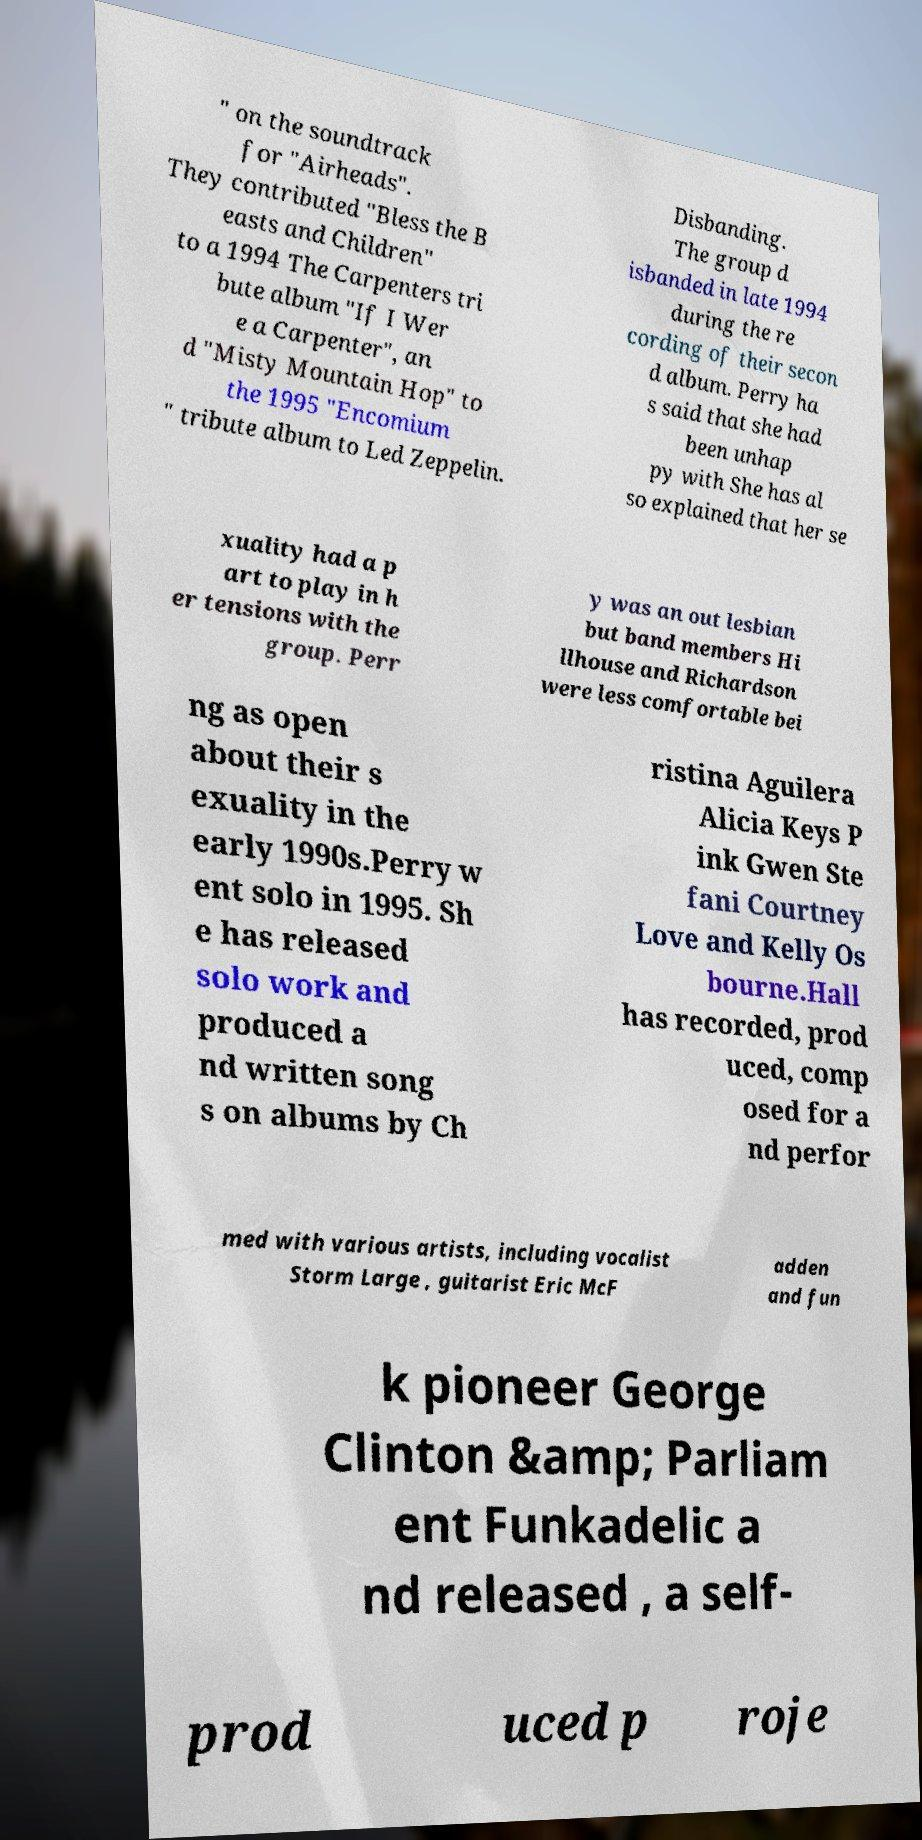I need the written content from this picture converted into text. Can you do that? " on the soundtrack for "Airheads". They contributed "Bless the B easts and Children" to a 1994 The Carpenters tri bute album "If I Wer e a Carpenter", an d "Misty Mountain Hop" to the 1995 "Encomium " tribute album to Led Zeppelin. Disbanding. The group d isbanded in late 1994 during the re cording of their secon d album. Perry ha s said that she had been unhap py with She has al so explained that her se xuality had a p art to play in h er tensions with the group. Perr y was an out lesbian but band members Hi llhouse and Richardson were less comfortable bei ng as open about their s exuality in the early 1990s.Perry w ent solo in 1995. Sh e has released solo work and produced a nd written song s on albums by Ch ristina Aguilera Alicia Keys P ink Gwen Ste fani Courtney Love and Kelly Os bourne.Hall has recorded, prod uced, comp osed for a nd perfor med with various artists, including vocalist Storm Large , guitarist Eric McF adden and fun k pioneer George Clinton &amp; Parliam ent Funkadelic a nd released , a self- prod uced p roje 